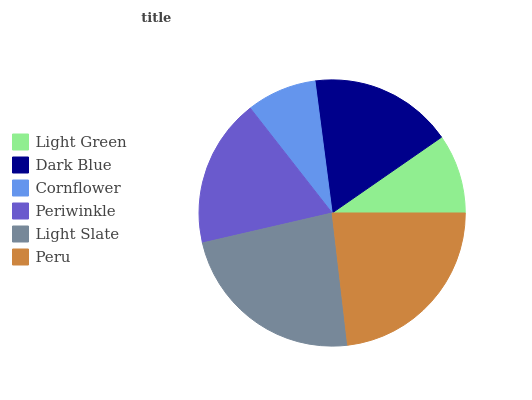Is Cornflower the minimum?
Answer yes or no. Yes. Is Light Slate the maximum?
Answer yes or no. Yes. Is Dark Blue the minimum?
Answer yes or no. No. Is Dark Blue the maximum?
Answer yes or no. No. Is Dark Blue greater than Light Green?
Answer yes or no. Yes. Is Light Green less than Dark Blue?
Answer yes or no. Yes. Is Light Green greater than Dark Blue?
Answer yes or no. No. Is Dark Blue less than Light Green?
Answer yes or no. No. Is Periwinkle the high median?
Answer yes or no. Yes. Is Dark Blue the low median?
Answer yes or no. Yes. Is Peru the high median?
Answer yes or no. No. Is Peru the low median?
Answer yes or no. No. 